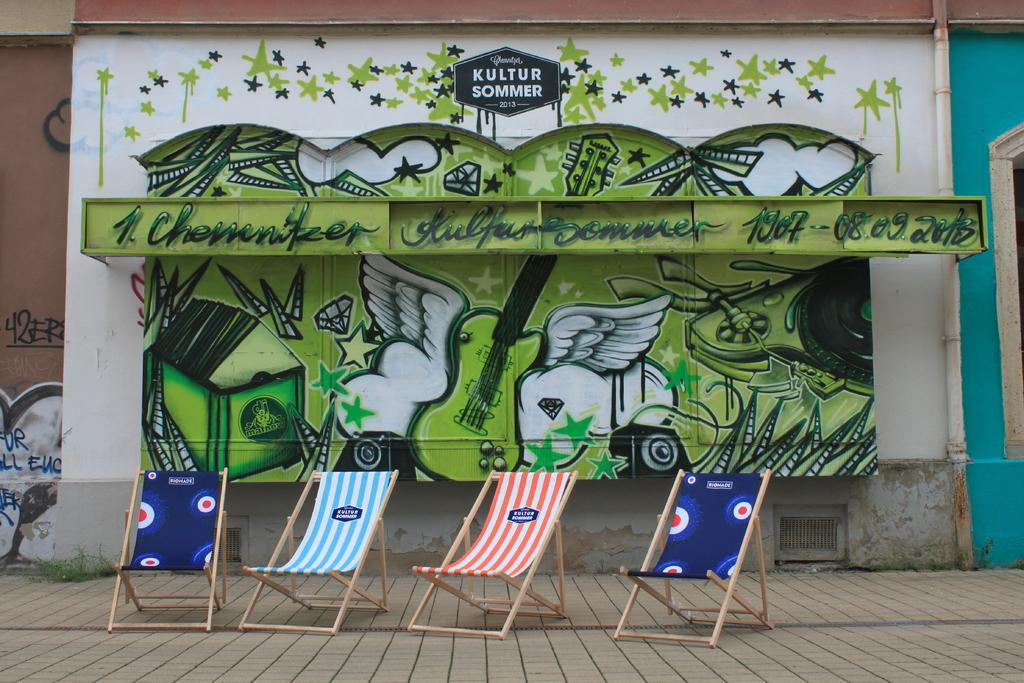How many chairs are visible in the image? There are four chairs in the middle of the image. What is located on the wall in the background of the image? There is a painting on the wall in the background of the image. What type of machine is being used by the duck in the image? There is no duck or machine present in the image. 